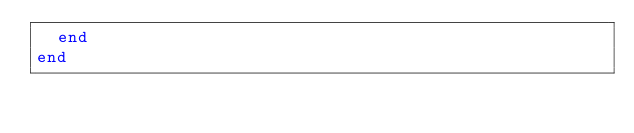Convert code to text. <code><loc_0><loc_0><loc_500><loc_500><_Ruby_>  end
end
</code> 